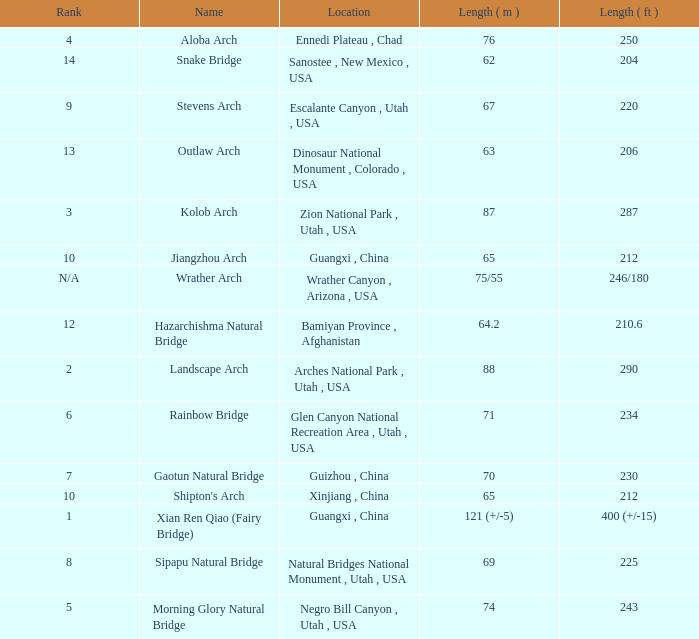Where is the longest arch with a length in meters of 63? Dinosaur National Monument , Colorado , USA. 